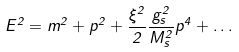<formula> <loc_0><loc_0><loc_500><loc_500>E ^ { 2 } = m ^ { 2 } + p ^ { 2 } + \frac { \xi ^ { 2 } } { 2 } \frac { g _ { s } ^ { 2 } } { M _ { s } ^ { 2 } } p ^ { 4 } + \dots</formula> 